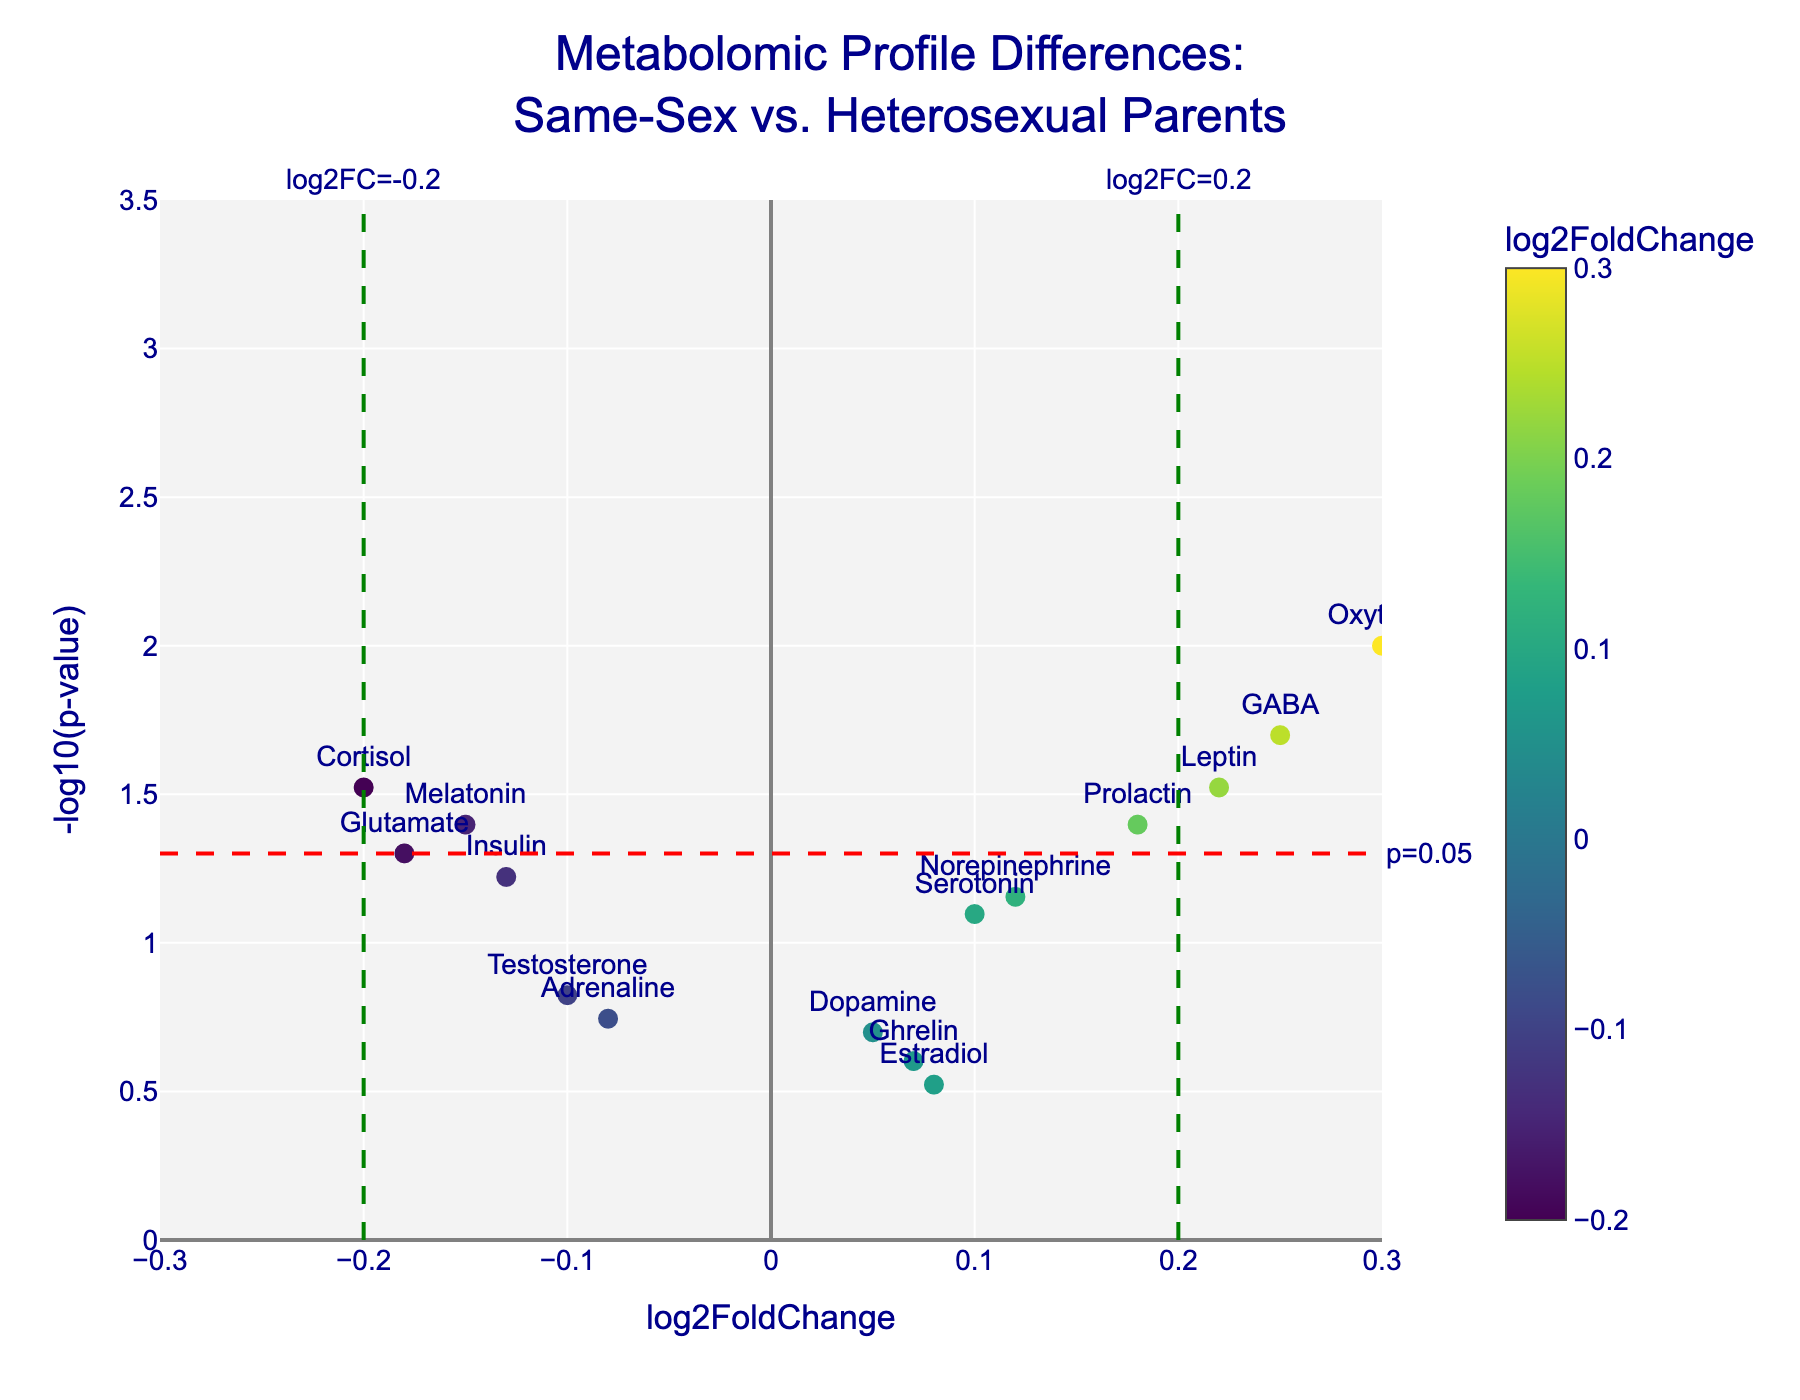what is the title of the plot? The title of the plot is displayed at the top and reads "Metabolomic Profile Differences: Same-Sex vs. Heterosexual Parents."
Answer: Metabolomic Profile Differences: Same-Sex vs. Heterosexual Parents what are the labels on the axes? The x-axis is labeled "log2FoldChange" and the y-axis is labeled "-log10(p-value)."
Answer: x-axis: log2FoldChange, y-axis: -log10(p-value) how many data points are shown in the plot? There are a total of 15 metabolites listed in the data, each represented by a point in the plot.
Answer: 15 which metabolite has the highest -log10(p-value) value? By looking at the y-axis, "Oxytocin" appears to have the highest -log10(p-value) value because it is plotted higher than all other points.
Answer: Oxytocin which metabolite has the lowest fold change? "Adrenaline" has the lowest fold change since its log2FoldChange value is close to -0.2, the lowest among the points.
Answer: Adrenaline which metabolites are considered statistically significant (p-value < 0.05)? Metabolites with a -log10(p-value) greater than -log10(0.05) (which corresponds to the red horizontal line) are significant. These are Cortisol, Oxytocin, Melatonin, GABA, Leptin, and Prolactin.
Answer: Cortisol, Oxytocin, Melatonin, GABA, Leptin, Prolactin which metabolite has the highest positive log2FoldChange value? "Oxytocin" has the highest positive log2FoldChange value as it is the right-most point on the plot.
Answer: Oxytocin how many metabolites have a log2FoldChange value between -0.2 and 0.2? There are 10 metabolites: Serotonin, Dopamine, Melatonin, Estradiol, Glutamate, Norepinephrine, Adrenaline, Insulin, Ghrelin, and Prolactin. This can be counted by identifying points within this range of log2FoldChange values.
Answer: 10 how many metabolites are above the significance threshold of p=0.05? To determine this, count the points above the -log10(0.05) line (approximately 1.3 on the y-axis). There are 6 such metabolites: Cortisol, Oxytocin, Melatonin, GABA, Leptin, and Prolactin.
Answer: 6 which metabolite has a log2FoldChange value closest to zero? "Dopamine" has the closest log2FoldChange value to zero, as its corresponding plot point is near the center of the x-axis.
Answer: Dopamine 